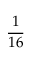Convert formula to latex. <formula><loc_0><loc_0><loc_500><loc_500>\frac { 1 } { 1 6 }</formula> 